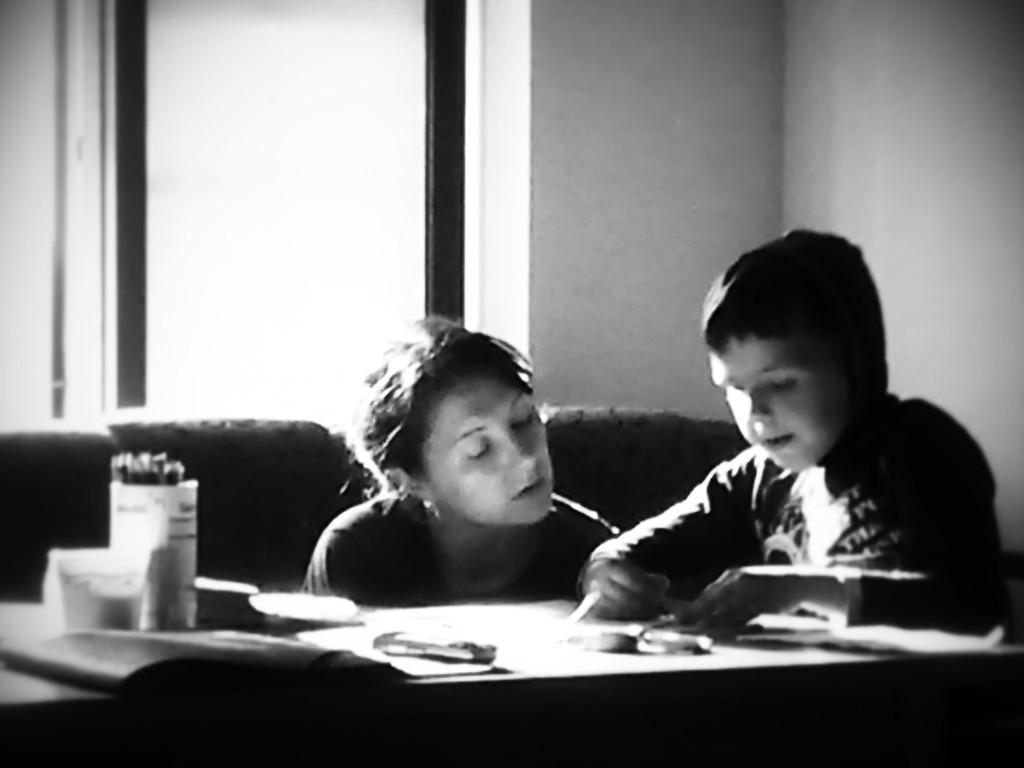In one or two sentences, can you explain what this image depicts? In the picture we can see a boy and a woman. The boy is sitting on a chair near the table. On the table we can find a pen stand, papers and some things. In the background we can find a chair, wall and a window. 